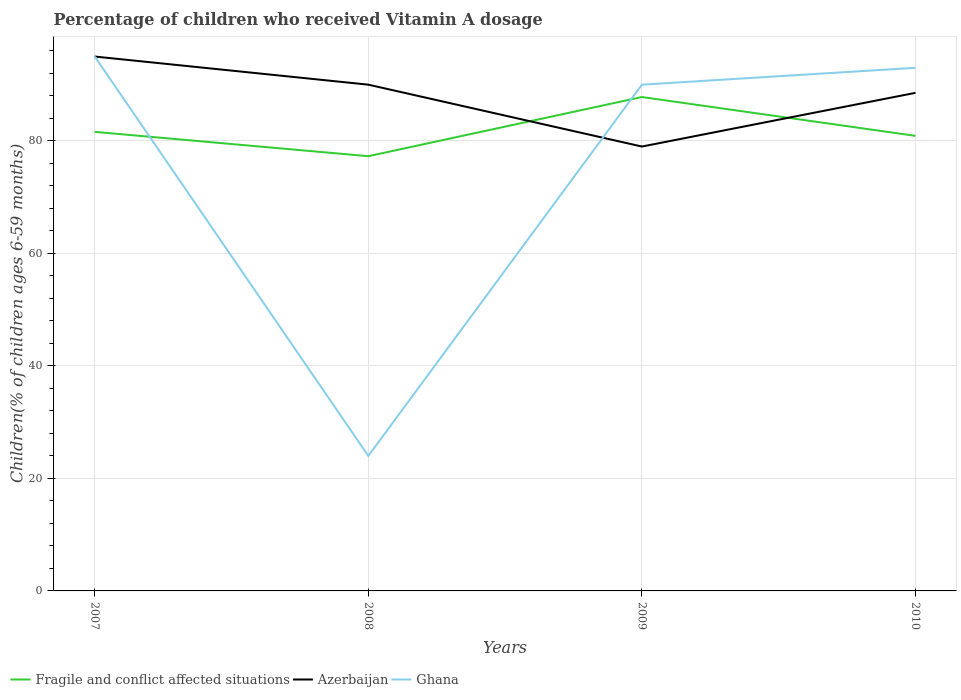How many different coloured lines are there?
Make the answer very short. 3. Across all years, what is the maximum percentage of children who received Vitamin A dosage in Azerbaijan?
Your answer should be compact. 79. In which year was the percentage of children who received Vitamin A dosage in Ghana maximum?
Keep it short and to the point. 2008. What is the total percentage of children who received Vitamin A dosage in Fragile and conflict affected situations in the graph?
Your answer should be very brief. -6.19. Is the percentage of children who received Vitamin A dosage in Ghana strictly greater than the percentage of children who received Vitamin A dosage in Fragile and conflict affected situations over the years?
Offer a terse response. No. How many years are there in the graph?
Your answer should be very brief. 4. Are the values on the major ticks of Y-axis written in scientific E-notation?
Your answer should be very brief. No. Does the graph contain grids?
Your answer should be very brief. Yes. Where does the legend appear in the graph?
Give a very brief answer. Bottom left. What is the title of the graph?
Your answer should be very brief. Percentage of children who received Vitamin A dosage. What is the label or title of the X-axis?
Your answer should be very brief. Years. What is the label or title of the Y-axis?
Make the answer very short. Children(% of children ages 6-59 months). What is the Children(% of children ages 6-59 months) in Fragile and conflict affected situations in 2007?
Your response must be concise. 81.61. What is the Children(% of children ages 6-59 months) in Azerbaijan in 2007?
Give a very brief answer. 95. What is the Children(% of children ages 6-59 months) of Ghana in 2007?
Give a very brief answer. 95. What is the Children(% of children ages 6-59 months) in Fragile and conflict affected situations in 2008?
Provide a succinct answer. 77.28. What is the Children(% of children ages 6-59 months) of Fragile and conflict affected situations in 2009?
Offer a terse response. 87.8. What is the Children(% of children ages 6-59 months) in Azerbaijan in 2009?
Provide a succinct answer. 79. What is the Children(% of children ages 6-59 months) in Fragile and conflict affected situations in 2010?
Ensure brevity in your answer.  80.9. What is the Children(% of children ages 6-59 months) of Azerbaijan in 2010?
Offer a very short reply. 88.55. What is the Children(% of children ages 6-59 months) in Ghana in 2010?
Give a very brief answer. 93. Across all years, what is the maximum Children(% of children ages 6-59 months) in Fragile and conflict affected situations?
Your answer should be compact. 87.8. Across all years, what is the maximum Children(% of children ages 6-59 months) in Ghana?
Your answer should be very brief. 95. Across all years, what is the minimum Children(% of children ages 6-59 months) of Fragile and conflict affected situations?
Your answer should be very brief. 77.28. Across all years, what is the minimum Children(% of children ages 6-59 months) in Azerbaijan?
Provide a succinct answer. 79. What is the total Children(% of children ages 6-59 months) in Fragile and conflict affected situations in the graph?
Your answer should be compact. 327.6. What is the total Children(% of children ages 6-59 months) in Azerbaijan in the graph?
Your answer should be very brief. 352.55. What is the total Children(% of children ages 6-59 months) in Ghana in the graph?
Make the answer very short. 302. What is the difference between the Children(% of children ages 6-59 months) in Fragile and conflict affected situations in 2007 and that in 2008?
Give a very brief answer. 4.33. What is the difference between the Children(% of children ages 6-59 months) of Azerbaijan in 2007 and that in 2008?
Make the answer very short. 5. What is the difference between the Children(% of children ages 6-59 months) in Ghana in 2007 and that in 2008?
Provide a succinct answer. 71. What is the difference between the Children(% of children ages 6-59 months) of Fragile and conflict affected situations in 2007 and that in 2009?
Provide a short and direct response. -6.19. What is the difference between the Children(% of children ages 6-59 months) of Azerbaijan in 2007 and that in 2009?
Offer a very short reply. 16. What is the difference between the Children(% of children ages 6-59 months) in Ghana in 2007 and that in 2009?
Give a very brief answer. 5. What is the difference between the Children(% of children ages 6-59 months) of Fragile and conflict affected situations in 2007 and that in 2010?
Make the answer very short. 0.71. What is the difference between the Children(% of children ages 6-59 months) in Azerbaijan in 2007 and that in 2010?
Your answer should be compact. 6.45. What is the difference between the Children(% of children ages 6-59 months) in Ghana in 2007 and that in 2010?
Your answer should be very brief. 2. What is the difference between the Children(% of children ages 6-59 months) of Fragile and conflict affected situations in 2008 and that in 2009?
Ensure brevity in your answer.  -10.52. What is the difference between the Children(% of children ages 6-59 months) in Azerbaijan in 2008 and that in 2009?
Provide a succinct answer. 11. What is the difference between the Children(% of children ages 6-59 months) in Ghana in 2008 and that in 2009?
Your response must be concise. -66. What is the difference between the Children(% of children ages 6-59 months) in Fragile and conflict affected situations in 2008 and that in 2010?
Your response must be concise. -3.62. What is the difference between the Children(% of children ages 6-59 months) of Azerbaijan in 2008 and that in 2010?
Your response must be concise. 1.45. What is the difference between the Children(% of children ages 6-59 months) in Ghana in 2008 and that in 2010?
Offer a very short reply. -69. What is the difference between the Children(% of children ages 6-59 months) of Fragile and conflict affected situations in 2009 and that in 2010?
Offer a very short reply. 6.9. What is the difference between the Children(% of children ages 6-59 months) in Azerbaijan in 2009 and that in 2010?
Give a very brief answer. -9.55. What is the difference between the Children(% of children ages 6-59 months) in Ghana in 2009 and that in 2010?
Offer a very short reply. -3. What is the difference between the Children(% of children ages 6-59 months) in Fragile and conflict affected situations in 2007 and the Children(% of children ages 6-59 months) in Azerbaijan in 2008?
Keep it short and to the point. -8.39. What is the difference between the Children(% of children ages 6-59 months) of Fragile and conflict affected situations in 2007 and the Children(% of children ages 6-59 months) of Ghana in 2008?
Keep it short and to the point. 57.61. What is the difference between the Children(% of children ages 6-59 months) of Fragile and conflict affected situations in 2007 and the Children(% of children ages 6-59 months) of Azerbaijan in 2009?
Provide a succinct answer. 2.61. What is the difference between the Children(% of children ages 6-59 months) in Fragile and conflict affected situations in 2007 and the Children(% of children ages 6-59 months) in Ghana in 2009?
Offer a very short reply. -8.39. What is the difference between the Children(% of children ages 6-59 months) in Fragile and conflict affected situations in 2007 and the Children(% of children ages 6-59 months) in Azerbaijan in 2010?
Offer a very short reply. -6.94. What is the difference between the Children(% of children ages 6-59 months) of Fragile and conflict affected situations in 2007 and the Children(% of children ages 6-59 months) of Ghana in 2010?
Your answer should be very brief. -11.39. What is the difference between the Children(% of children ages 6-59 months) of Fragile and conflict affected situations in 2008 and the Children(% of children ages 6-59 months) of Azerbaijan in 2009?
Make the answer very short. -1.72. What is the difference between the Children(% of children ages 6-59 months) of Fragile and conflict affected situations in 2008 and the Children(% of children ages 6-59 months) of Ghana in 2009?
Your answer should be compact. -12.72. What is the difference between the Children(% of children ages 6-59 months) of Azerbaijan in 2008 and the Children(% of children ages 6-59 months) of Ghana in 2009?
Ensure brevity in your answer.  0. What is the difference between the Children(% of children ages 6-59 months) of Fragile and conflict affected situations in 2008 and the Children(% of children ages 6-59 months) of Azerbaijan in 2010?
Provide a short and direct response. -11.27. What is the difference between the Children(% of children ages 6-59 months) in Fragile and conflict affected situations in 2008 and the Children(% of children ages 6-59 months) in Ghana in 2010?
Offer a very short reply. -15.72. What is the difference between the Children(% of children ages 6-59 months) in Fragile and conflict affected situations in 2009 and the Children(% of children ages 6-59 months) in Azerbaijan in 2010?
Give a very brief answer. -0.75. What is the difference between the Children(% of children ages 6-59 months) in Fragile and conflict affected situations in 2009 and the Children(% of children ages 6-59 months) in Ghana in 2010?
Your answer should be very brief. -5.2. What is the average Children(% of children ages 6-59 months) in Fragile and conflict affected situations per year?
Give a very brief answer. 81.9. What is the average Children(% of children ages 6-59 months) in Azerbaijan per year?
Keep it short and to the point. 88.14. What is the average Children(% of children ages 6-59 months) in Ghana per year?
Keep it short and to the point. 75.5. In the year 2007, what is the difference between the Children(% of children ages 6-59 months) of Fragile and conflict affected situations and Children(% of children ages 6-59 months) of Azerbaijan?
Offer a terse response. -13.39. In the year 2007, what is the difference between the Children(% of children ages 6-59 months) of Fragile and conflict affected situations and Children(% of children ages 6-59 months) of Ghana?
Provide a succinct answer. -13.39. In the year 2008, what is the difference between the Children(% of children ages 6-59 months) in Fragile and conflict affected situations and Children(% of children ages 6-59 months) in Azerbaijan?
Give a very brief answer. -12.72. In the year 2008, what is the difference between the Children(% of children ages 6-59 months) of Fragile and conflict affected situations and Children(% of children ages 6-59 months) of Ghana?
Your response must be concise. 53.28. In the year 2009, what is the difference between the Children(% of children ages 6-59 months) of Fragile and conflict affected situations and Children(% of children ages 6-59 months) of Azerbaijan?
Offer a very short reply. 8.8. In the year 2009, what is the difference between the Children(% of children ages 6-59 months) of Fragile and conflict affected situations and Children(% of children ages 6-59 months) of Ghana?
Your answer should be very brief. -2.2. In the year 2009, what is the difference between the Children(% of children ages 6-59 months) in Azerbaijan and Children(% of children ages 6-59 months) in Ghana?
Your response must be concise. -11. In the year 2010, what is the difference between the Children(% of children ages 6-59 months) of Fragile and conflict affected situations and Children(% of children ages 6-59 months) of Azerbaijan?
Offer a terse response. -7.65. In the year 2010, what is the difference between the Children(% of children ages 6-59 months) in Fragile and conflict affected situations and Children(% of children ages 6-59 months) in Ghana?
Offer a terse response. -12.1. In the year 2010, what is the difference between the Children(% of children ages 6-59 months) of Azerbaijan and Children(% of children ages 6-59 months) of Ghana?
Give a very brief answer. -4.45. What is the ratio of the Children(% of children ages 6-59 months) in Fragile and conflict affected situations in 2007 to that in 2008?
Your answer should be very brief. 1.06. What is the ratio of the Children(% of children ages 6-59 months) of Azerbaijan in 2007 to that in 2008?
Make the answer very short. 1.06. What is the ratio of the Children(% of children ages 6-59 months) in Ghana in 2007 to that in 2008?
Provide a short and direct response. 3.96. What is the ratio of the Children(% of children ages 6-59 months) of Fragile and conflict affected situations in 2007 to that in 2009?
Ensure brevity in your answer.  0.93. What is the ratio of the Children(% of children ages 6-59 months) of Azerbaijan in 2007 to that in 2009?
Offer a very short reply. 1.2. What is the ratio of the Children(% of children ages 6-59 months) of Ghana in 2007 to that in 2009?
Your answer should be compact. 1.06. What is the ratio of the Children(% of children ages 6-59 months) of Fragile and conflict affected situations in 2007 to that in 2010?
Give a very brief answer. 1.01. What is the ratio of the Children(% of children ages 6-59 months) of Azerbaijan in 2007 to that in 2010?
Ensure brevity in your answer.  1.07. What is the ratio of the Children(% of children ages 6-59 months) of Ghana in 2007 to that in 2010?
Make the answer very short. 1.02. What is the ratio of the Children(% of children ages 6-59 months) in Fragile and conflict affected situations in 2008 to that in 2009?
Give a very brief answer. 0.88. What is the ratio of the Children(% of children ages 6-59 months) of Azerbaijan in 2008 to that in 2009?
Offer a very short reply. 1.14. What is the ratio of the Children(% of children ages 6-59 months) of Ghana in 2008 to that in 2009?
Ensure brevity in your answer.  0.27. What is the ratio of the Children(% of children ages 6-59 months) of Fragile and conflict affected situations in 2008 to that in 2010?
Offer a terse response. 0.96. What is the ratio of the Children(% of children ages 6-59 months) in Azerbaijan in 2008 to that in 2010?
Ensure brevity in your answer.  1.02. What is the ratio of the Children(% of children ages 6-59 months) in Ghana in 2008 to that in 2010?
Ensure brevity in your answer.  0.26. What is the ratio of the Children(% of children ages 6-59 months) of Fragile and conflict affected situations in 2009 to that in 2010?
Make the answer very short. 1.09. What is the ratio of the Children(% of children ages 6-59 months) in Azerbaijan in 2009 to that in 2010?
Give a very brief answer. 0.89. What is the ratio of the Children(% of children ages 6-59 months) of Ghana in 2009 to that in 2010?
Your response must be concise. 0.97. What is the difference between the highest and the second highest Children(% of children ages 6-59 months) in Fragile and conflict affected situations?
Your response must be concise. 6.19. What is the difference between the highest and the second highest Children(% of children ages 6-59 months) of Azerbaijan?
Provide a succinct answer. 5. What is the difference between the highest and the lowest Children(% of children ages 6-59 months) in Fragile and conflict affected situations?
Ensure brevity in your answer.  10.52. 